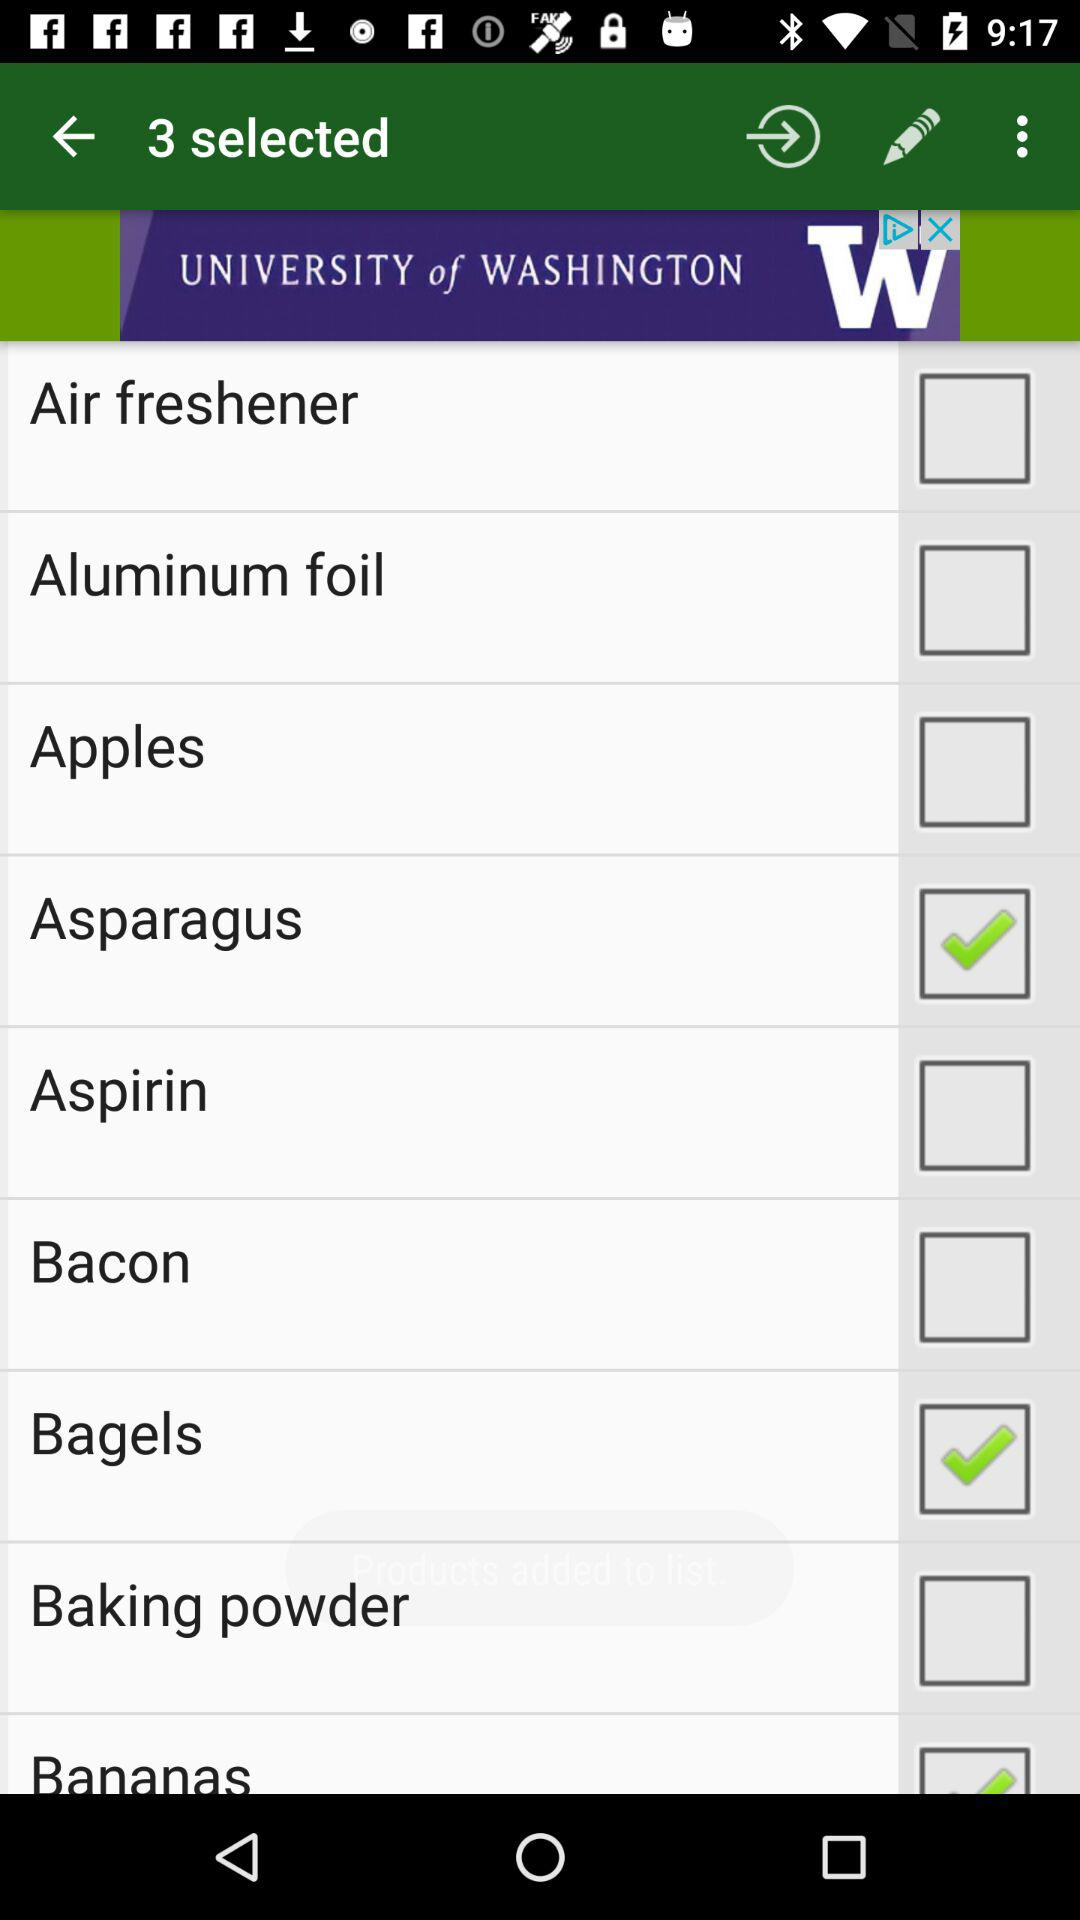Which items are selected? The selected items are "Asparagus" and "Bagels". 